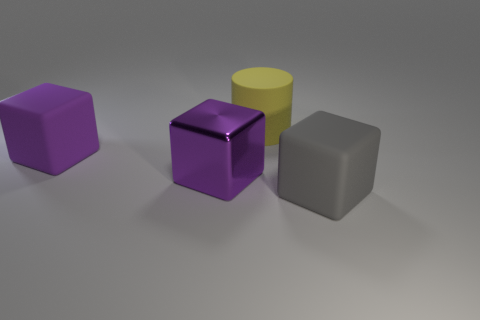Is the number of objects behind the purple rubber thing the same as the number of purple matte cubes?
Your response must be concise. Yes. Is there another object of the same color as the metal object?
Provide a succinct answer. Yes. Is the gray rubber block the same size as the purple matte block?
Ensure brevity in your answer.  Yes. What is the size of the thing in front of the purple cube to the right of the large purple matte cube?
Provide a succinct answer. Large. There is a object that is both right of the purple rubber thing and behind the purple metal cube; what size is it?
Offer a terse response. Large. How many metal things are the same size as the yellow matte object?
Provide a short and direct response. 1. What number of matte objects are large purple spheres or big yellow things?
Ensure brevity in your answer.  1. What is the size of the rubber block that is the same color as the metal object?
Make the answer very short. Large. There is a purple object that is in front of the big matte block to the left of the big yellow rubber cylinder; what is its material?
Ensure brevity in your answer.  Metal. What number of things are either yellow matte cylinders or large rubber objects that are behind the big gray object?
Provide a succinct answer. 2. 